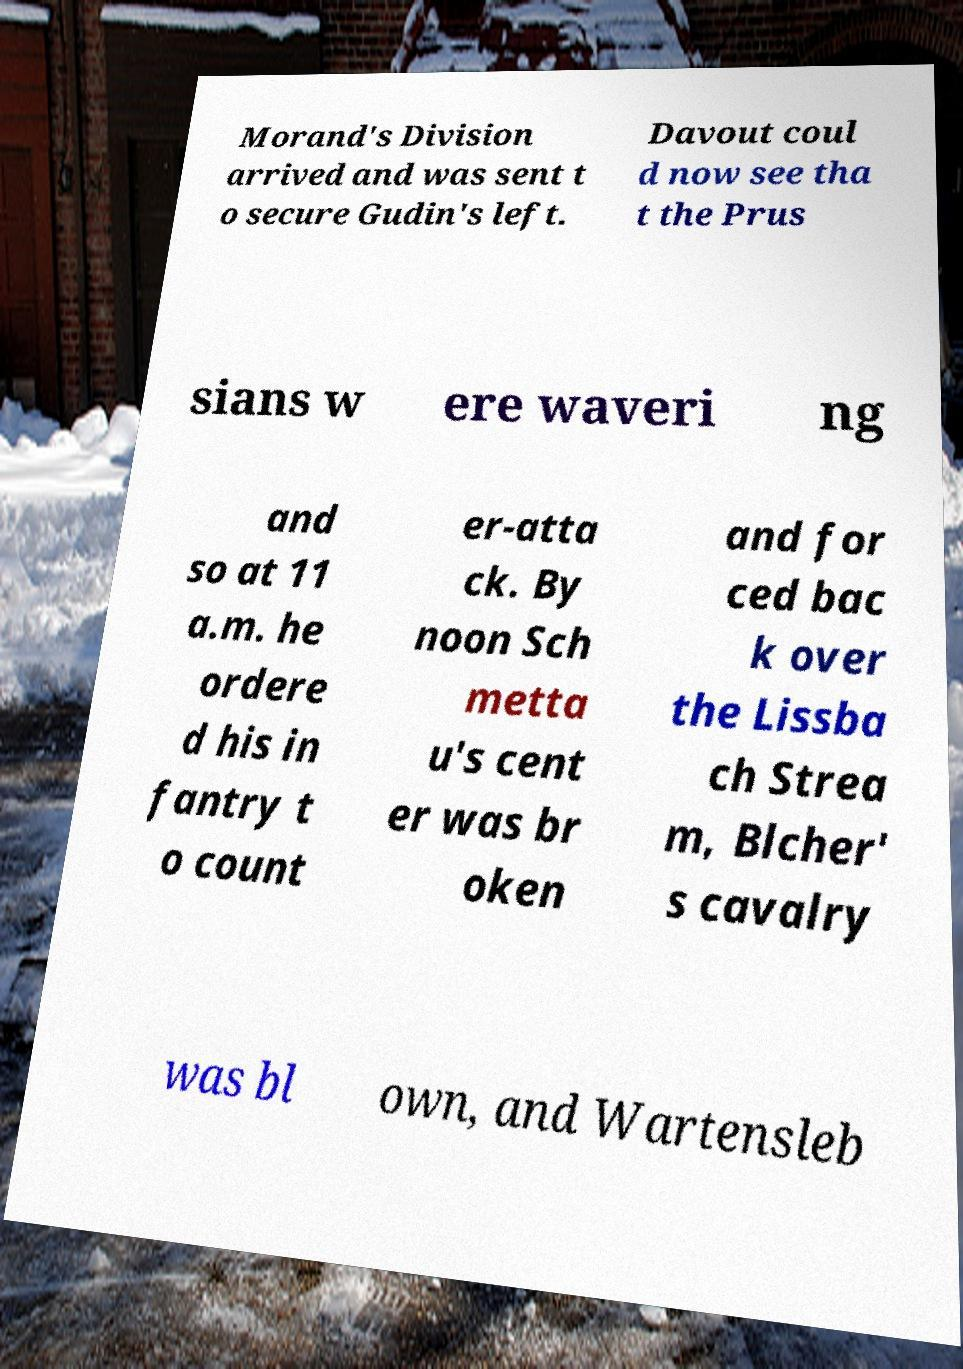Please read and relay the text visible in this image. What does it say? Morand's Division arrived and was sent t o secure Gudin's left. Davout coul d now see tha t the Prus sians w ere waveri ng and so at 11 a.m. he ordere d his in fantry t o count er-atta ck. By noon Sch metta u's cent er was br oken and for ced bac k over the Lissba ch Strea m, Blcher' s cavalry was bl own, and Wartensleb 